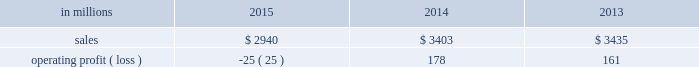Augusta , georgia mill and $ 2 million of costs associated with the sale of the shorewood business .
Consumer packaging .
North american consumer packaging net sales were $ 1.9 billion in 2015 compared with $ 2.0 billion in 2014 and $ 2.0 billion in 2013 .
Operating profits were $ 81 million ( $ 91 million excluding the cost associated with the planned conversion of our riegelwood mill to 100% ( 100 % ) pulp production , net of proceeds from the sale of the carolina coated bristols brand , and sheet plant closure costs ) in 2015 compared with $ 92 million ( $ 100 million excluding sheet plant closure costs ) in 2014 and $ 63 million ( $ 110 million excluding paper machine shutdown costs and costs related to the sale of the shorewood business ) in 2013 .
Coated paperboard sales volumes in 2015 were lower than in 2014 reflecting weaker market demand .
The business took about 77000 tons of market-related downtime in 2015 compared with about 41000 tons in 2014 .
Average sales price realizations increased modestly year over year as competitive pressures in the current year only partially offset the impact of sales price increases implemented in 2014 .
Input costs decreased for energy and chemicals , but wood costs increased .
Planned maintenance downtime costs were $ 10 million lower in 2015 .
Operating costs were higher , mainly due to inflation and overhead costs .
Foodservice sales volumes increased in 2015 compared with 2014 reflecting strong market demand .
Average sales margins increased due to lower resin costs and a more favorable mix .
Operating costs and distribution costs were both higher .
Looking ahead to the first quarter of 2016 , coated paperboard sales volumes are expected to be slightly lower than in the fourth quarter of 2015 due to our exit from the coated bristols market .
Average sales price realizations are expected to be flat , but margins should benefit from a more favorable product mix .
Input costs are expected to be higher for wood , chemicals and energy .
Planned maintenance downtime costs should be $ 4 million higher with a planned maintenance outage scheduled at our augusta mill in the first quarter .
Foodservice sales volumes are expected to be seasonally lower .
Average sales margins are expected to improve due to a more favorable mix .
Operating costs are expected to decrease .
European consumer packaging net sales in 2015 were $ 319 million compared with $ 365 million in 2014 and $ 380 million in 2013 .
Operating profits in 2015 were $ 87 million compared with $ 91 million in 2014 and $ 100 million in 2013 .
Sales volumes in 2015 compared with 2014 increased in europe , but decreased in russia .
Average sales margins improved in russia due to slightly higher average sales price realizations and a more favorable mix .
In europe average sales margins decreased reflecting lower average sales price realizations and an unfavorable mix .
Input costs were lower in europe , primarily for wood and energy , but were higher in russia , primarily for wood .
Looking forward to the first quarter of 2016 , compared with the fourth quarter of 2015 , sales volumes are expected to be stable .
Average sales price realizations are expected to be slightly higher in both russia and europe .
Input costs are expected to be flat , while operating costs are expected to increase .
Asian consumer packaging the company sold its 55% ( 55 % ) equity share in the ip-sun jv in october 2015 .
Net sales and operating profits presented below include results through september 30 , 2015 .
Net sales were $ 682 million in 2015 compared with $ 1.0 billion in 2014 and $ 1.1 billion in 2013 .
Operating profits in 2015 were a loss of $ 193 million ( a loss of $ 19 million excluding goodwill and other asset impairment costs ) compared with losses of $ 5 million in 2014 and $ 2 million in 2013 .
Sales volumes and average sales price realizations were lower in 2015 due to over-supplied market conditions and competitive pressures .
Average sales margins were also negatively impacted by a less favorable mix .
Input costs and freight costs were lower and operating costs also decreased .
On october 13 , 2015 , the company finalized the sale of its 55% ( 55 % ) interest in ip asia coated paperboard ( ip- sun jv ) business , within the company's consumer packaging segment , to its chinese coated board joint venture partner , shandong sun holding group co. , ltd .
For rmb 149 million ( approximately usd $ 23 million ) .
During the third quarter of 2015 , a determination was made that the current book value of the asset group exceeded its estimated fair value of $ 23 million , which was the agreed upon selling price .
The 2015 loss includes the net pre-tax impairment charge of $ 174 million ( $ 113 million after taxes ) .
A pre-tax charge of $ 186 million was recorded during the third quarter in the company's consumer packaging segment to write down the long-lived assets of this business to their estimated fair value .
In the fourth quarter of 2015 , upon the sale and corresponding deconsolidation of ip-sun jv from the company's consolidated balance sheet , final adjustments were made resulting in a reduction of the impairment of $ 12 million .
The amount of pre-tax losses related to noncontrolling interest of the ip-sun jv included in the company's consolidated statement of operations for the years ended december 31 , 2015 , 2014 and 2013 were $ 19 million , $ 12 million and $ 8 million , respectively .
The amount of pre-tax losses related to the ip-sun jv included in the company's .
What percentage of consumer packaging sales where from north american consumer packaging in 2015? 
Computations: ((1.9 * 1000) / 2940)
Answer: 0.64626. 